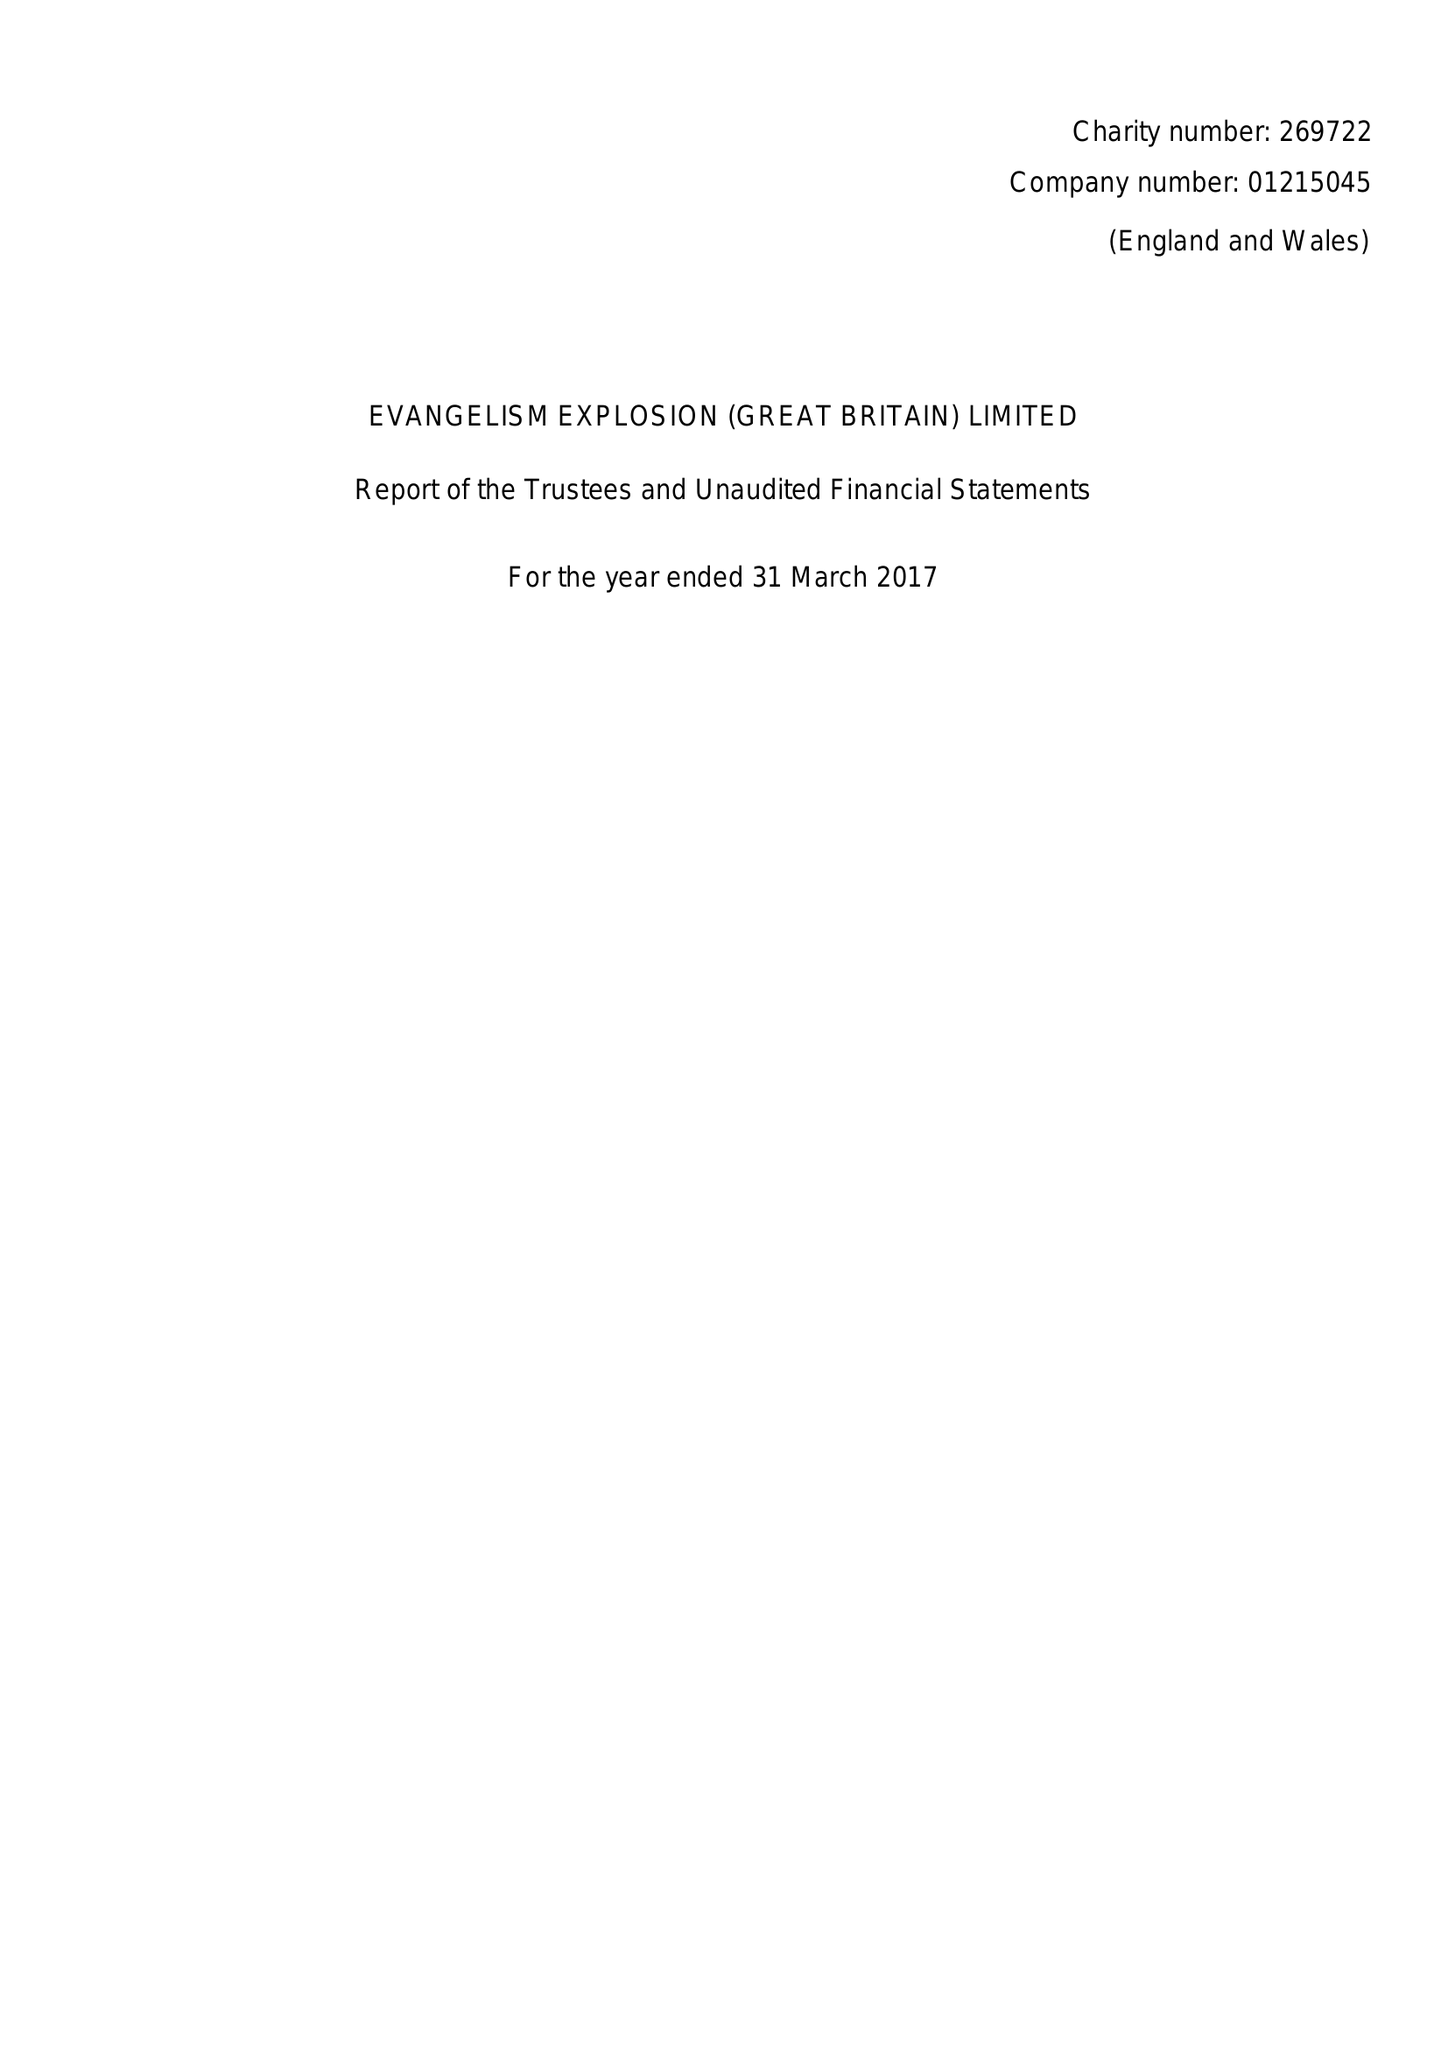What is the value for the charity_number?
Answer the question using a single word or phrase. 269722 